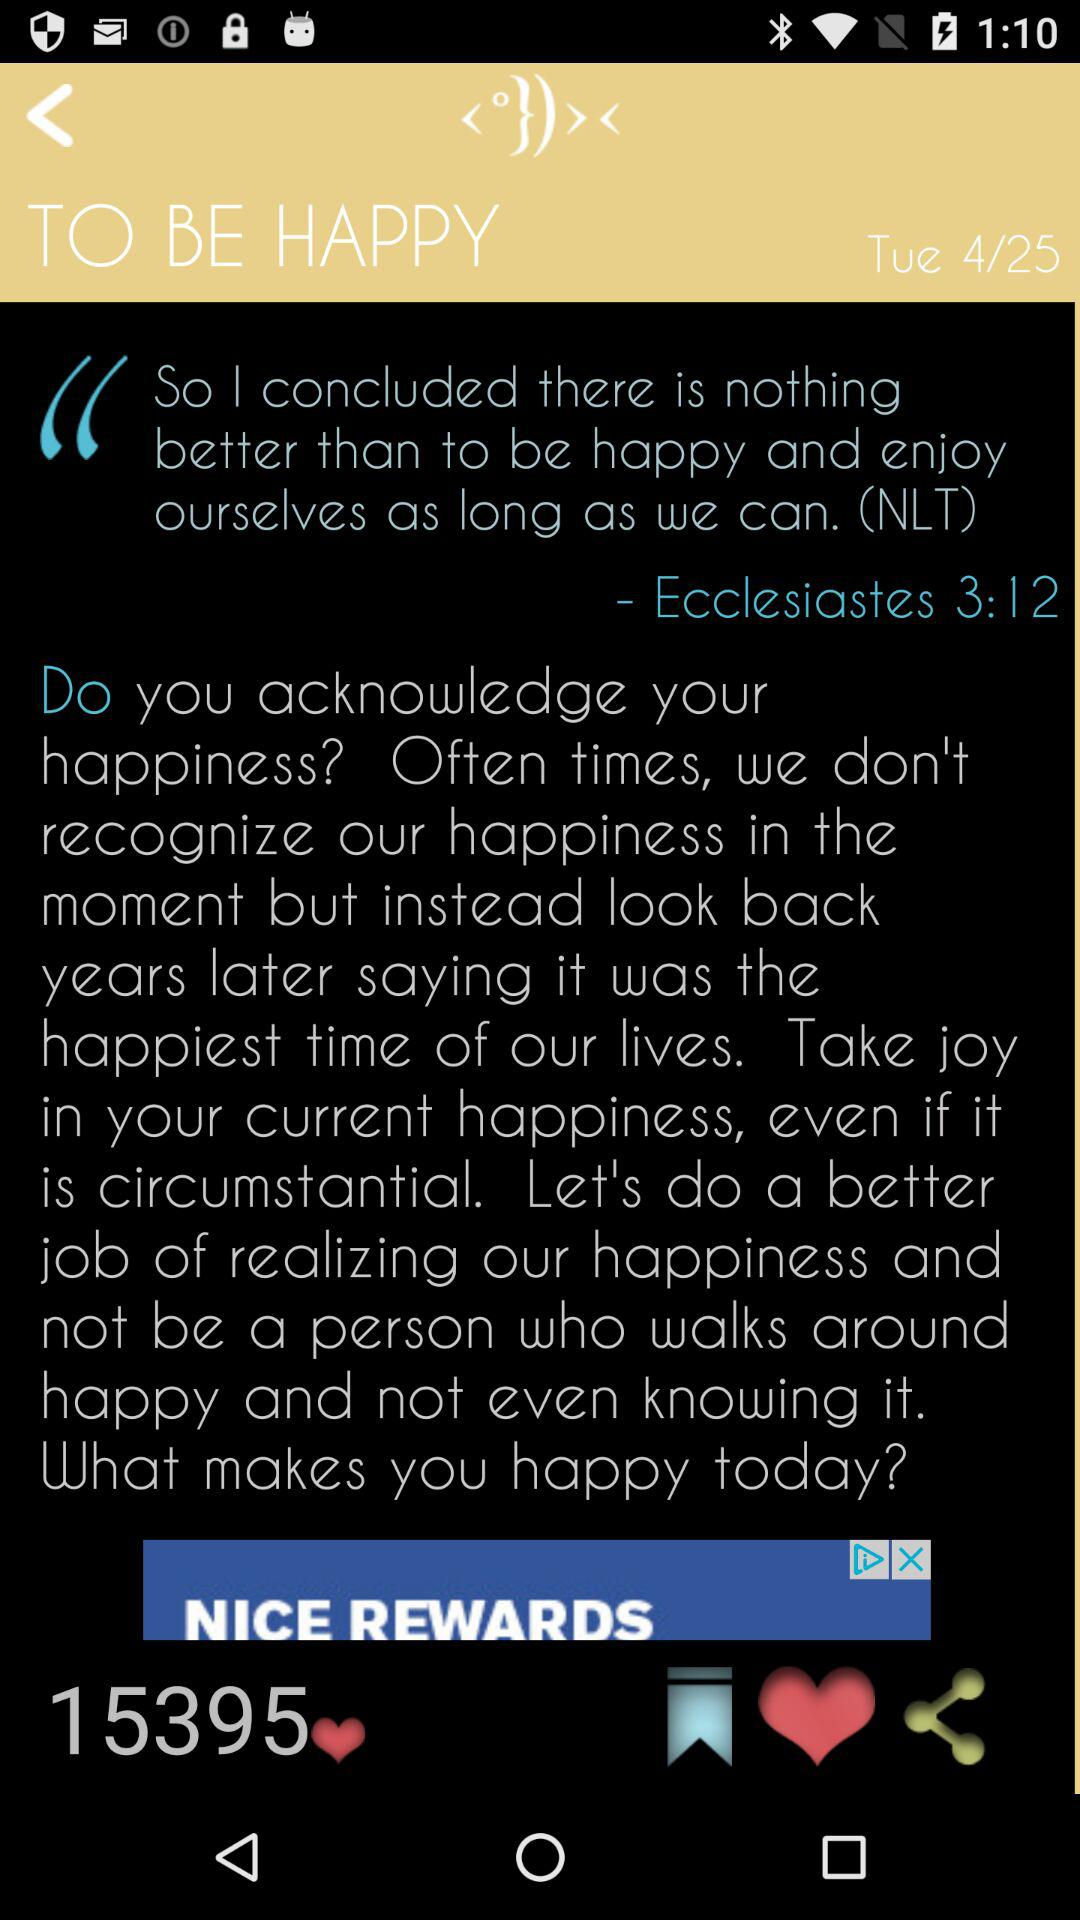What is the date? The date is Tuesday, April 25. 